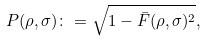<formula> <loc_0><loc_0><loc_500><loc_500>P ( \rho , \sigma ) \colon = \sqrt { 1 - \bar { F } ( \rho , \sigma ) ^ { 2 } } ,</formula> 